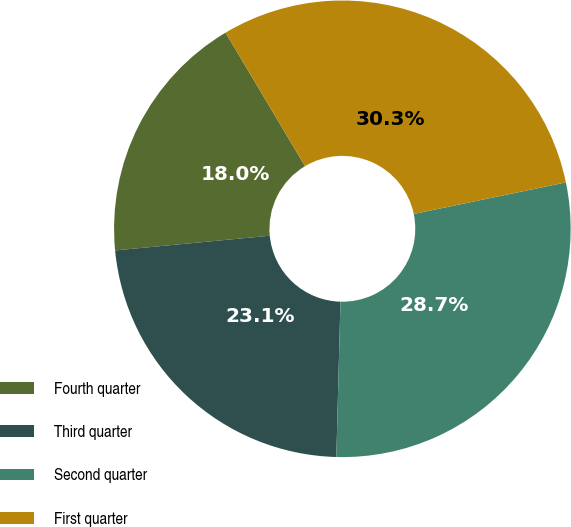Convert chart. <chart><loc_0><loc_0><loc_500><loc_500><pie_chart><fcel>Fourth quarter<fcel>Third quarter<fcel>Second quarter<fcel>First quarter<nl><fcel>17.96%<fcel>23.07%<fcel>28.68%<fcel>30.29%<nl></chart> 